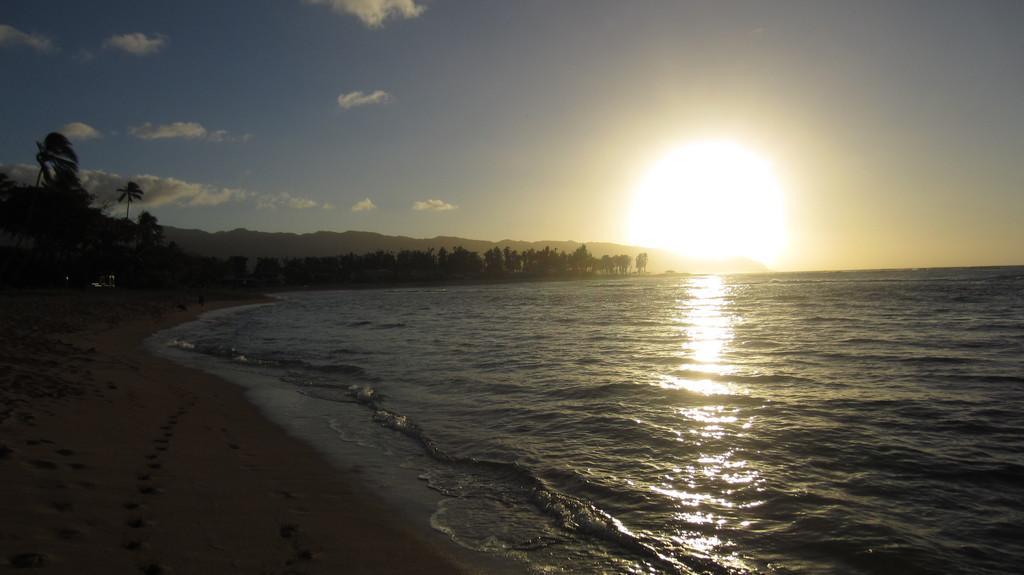Could you give a brief overview of what you see in this image? In this image we can see a sea. There is a sun in the sky. There is a reflection of sunlight on the sea water surface. There are many trees in the image. There is a beach at the left side of the image. There is a slightly cloudy sky in the image. 